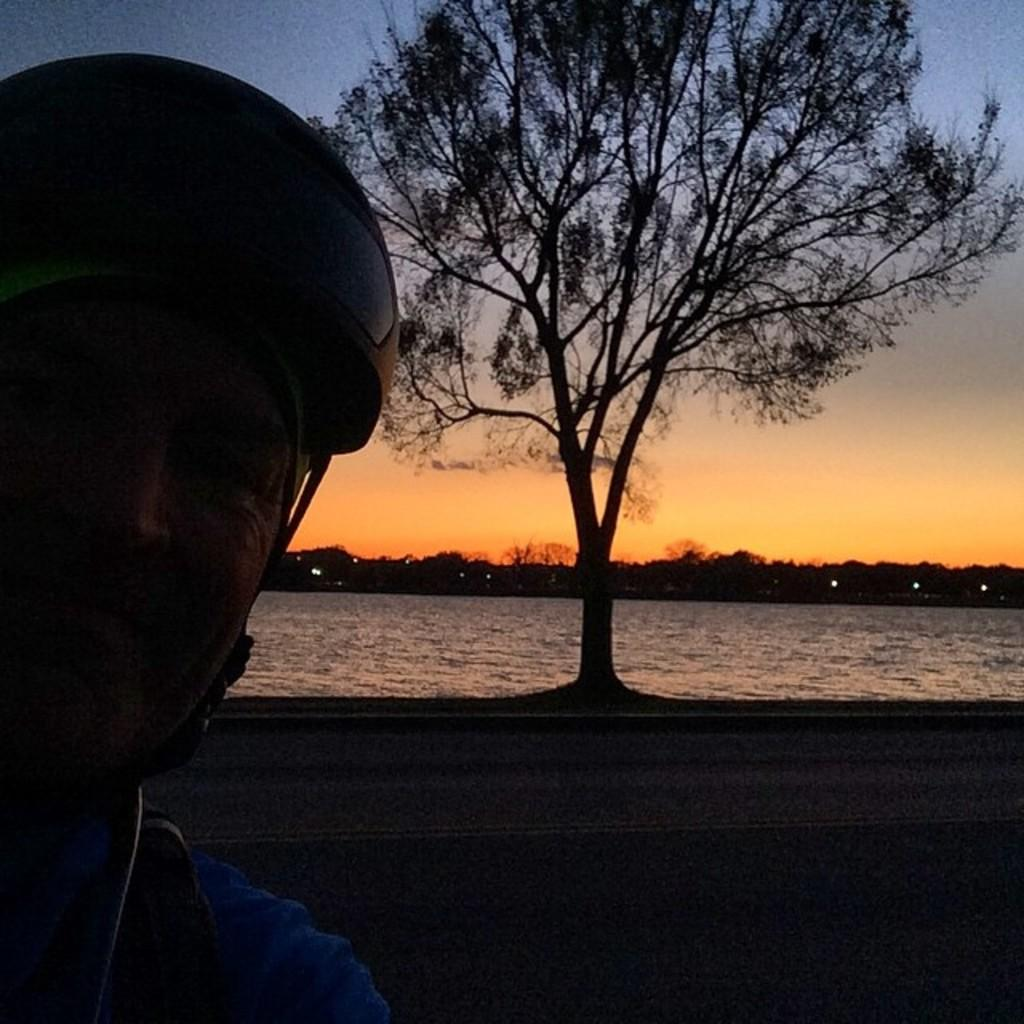Who is present in the image? There is a man in the image. What is the man wearing on his head? The man is wearing a helmet. What can be seen near the man? There is a tree near the man. What is visible in the image besides the man and the tree? There is water visible in the image, as well as trees in the background and the sky. What is the weather like in the image? The sky is visible, and there is sunshine in the sky, indicating that it is a sunny day. What type of cheese is being served at the man's birth celebration in the image? There is no cheese or birth celebration present in the image; it features a man wearing a helmet near a tree with water and sky visible in the background. 